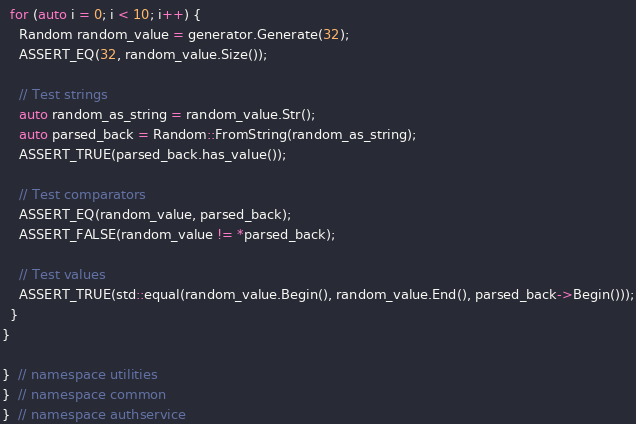Convert code to text. <code><loc_0><loc_0><loc_500><loc_500><_C++_>
  for (auto i = 0; i < 10; i++) {
    Random random_value = generator.Generate(32);
    ASSERT_EQ(32, random_value.Size());

    // Test strings
    auto random_as_string = random_value.Str();
    auto parsed_back = Random::FromString(random_as_string);
    ASSERT_TRUE(parsed_back.has_value());

    // Test comparators
    ASSERT_EQ(random_value, parsed_back);
    ASSERT_FALSE(random_value != *parsed_back);

    // Test values
    ASSERT_TRUE(std::equal(random_value.Begin(), random_value.End(), parsed_back->Begin()));
  }
}

}  // namespace utilities
}  // namespace common
}  // namespace authservice</code> 